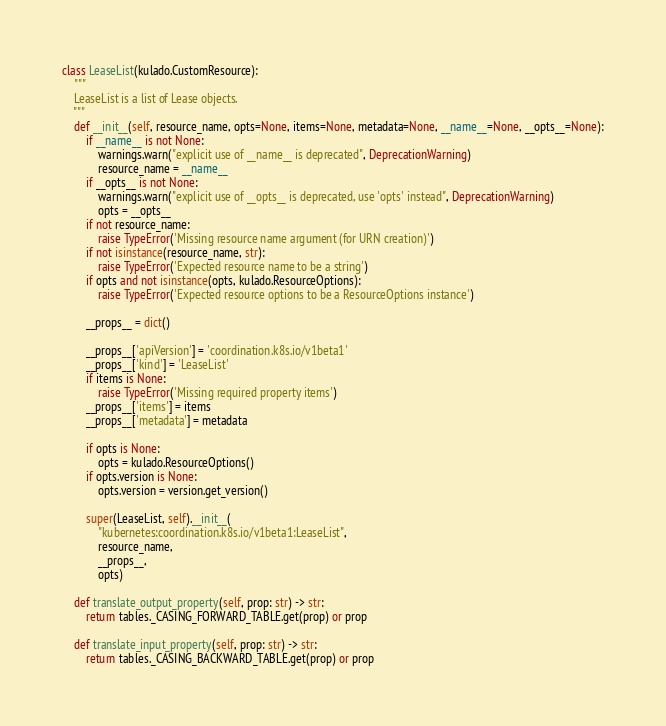<code> <loc_0><loc_0><loc_500><loc_500><_Python_>class LeaseList(kulado.CustomResource):
    """
    LeaseList is a list of Lease objects.
    """
    def __init__(self, resource_name, opts=None, items=None, metadata=None, __name__=None, __opts__=None):
        if __name__ is not None:
            warnings.warn("explicit use of __name__ is deprecated", DeprecationWarning)
            resource_name = __name__
        if __opts__ is not None:
            warnings.warn("explicit use of __opts__ is deprecated, use 'opts' instead", DeprecationWarning)
            opts = __opts__
        if not resource_name:
            raise TypeError('Missing resource name argument (for URN creation)')
        if not isinstance(resource_name, str):
            raise TypeError('Expected resource name to be a string')
        if opts and not isinstance(opts, kulado.ResourceOptions):
            raise TypeError('Expected resource options to be a ResourceOptions instance')

        __props__ = dict()

        __props__['apiVersion'] = 'coordination.k8s.io/v1beta1'
        __props__['kind'] = 'LeaseList'
        if items is None:
            raise TypeError('Missing required property items')
        __props__['items'] = items
        __props__['metadata'] = metadata

        if opts is None:
            opts = kulado.ResourceOptions()
        if opts.version is None:
            opts.version = version.get_version()

        super(LeaseList, self).__init__(
            "kubernetes:coordination.k8s.io/v1beta1:LeaseList",
            resource_name,
            __props__,
            opts)

    def translate_output_property(self, prop: str) -> str:
        return tables._CASING_FORWARD_TABLE.get(prop) or prop

    def translate_input_property(self, prop: str) -> str:
        return tables._CASING_BACKWARD_TABLE.get(prop) or prop
</code> 